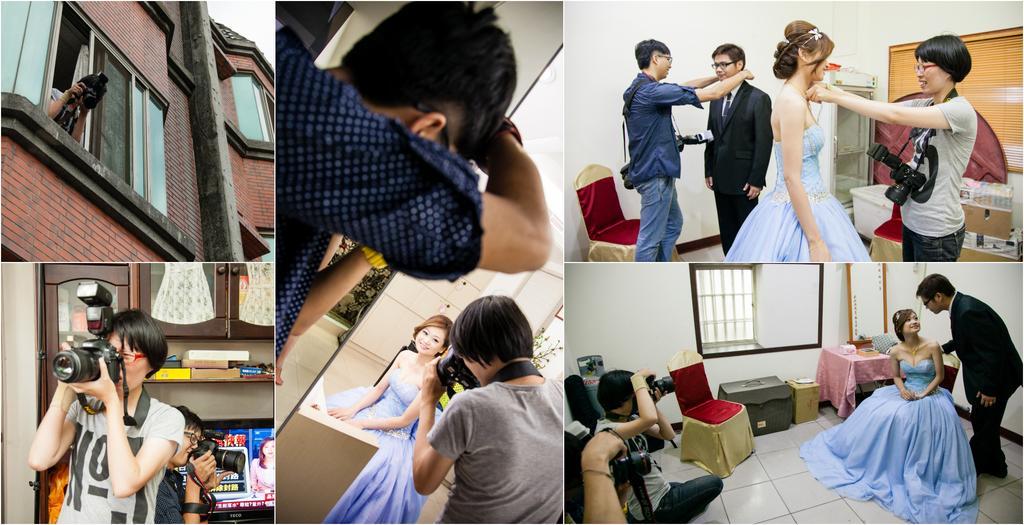Please provide a concise description of this image. In this picture we can see a collage image were here person standing at window and holding camera in his hand and in this we can see woman holding camera and taking picture and in background we can see racks with book and this three are of same image where woman dressed very nicely and taking picture of her. 